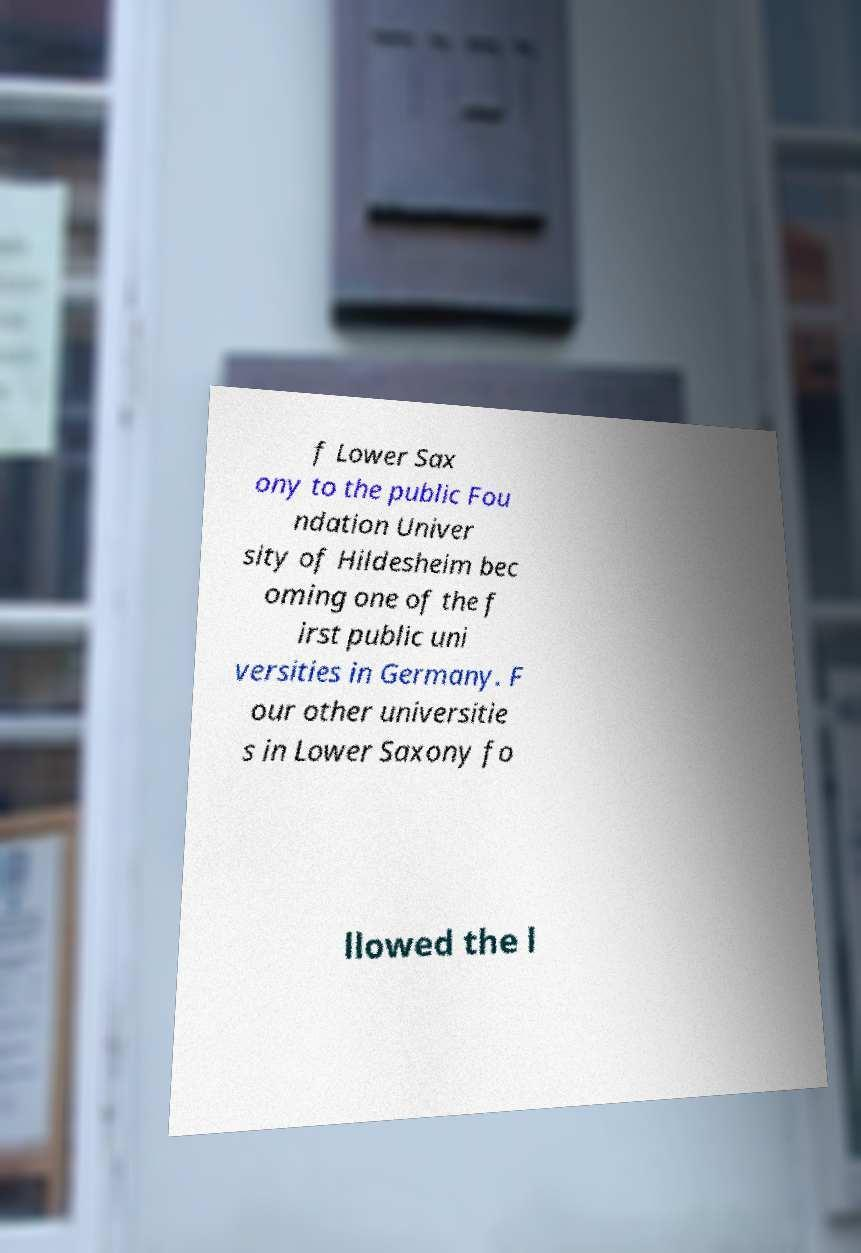Could you extract and type out the text from this image? f Lower Sax ony to the public Fou ndation Univer sity of Hildesheim bec oming one of the f irst public uni versities in Germany. F our other universitie s in Lower Saxony fo llowed the l 